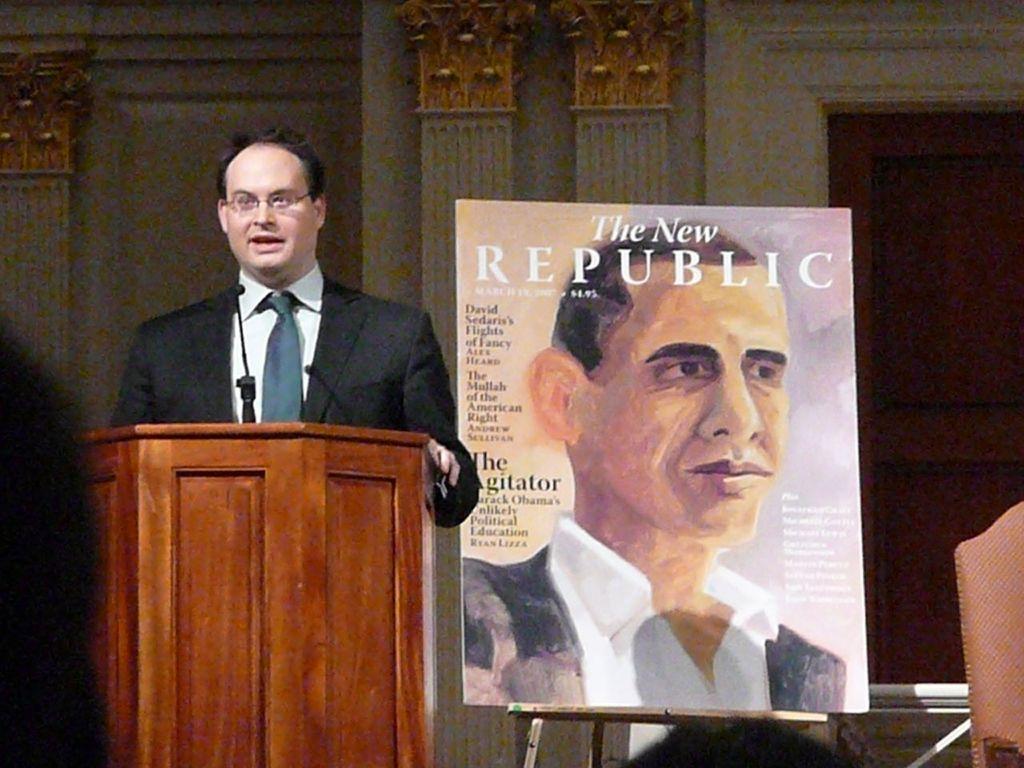How would you summarize this image in a sentence or two? In this image we can see a person talking, in front of him there is a podium, and a mic, beside to him there is a board on the stand, on the board, we can see a painting of a person, and also we can see text on it, there are pillars, a door, and the wall. 